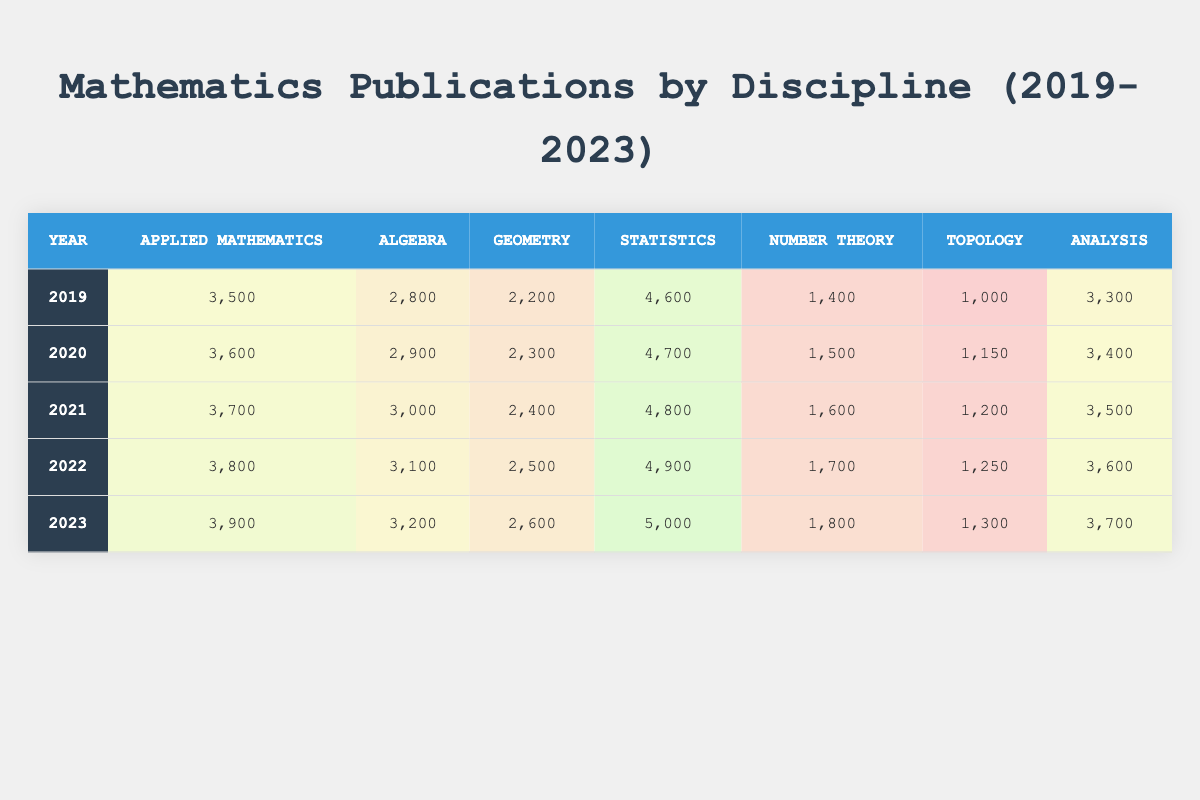What was the number of statistics publications in 2021? In the row for the year 2021, the column for statistics shows the value 4,800.
Answer: 4,800 Which discipline had the highest publication count in 2023? In the year 2023, the highest value in the table is found under the statistics column with 5,000 publications.
Answer: Statistics How many publications were there in applied mathematics between 2019 and 2023? The applied mathematics publications for the years 2019 to 2023 are 3,500, 3,600, 3,700, 3,800, and 3,900. Summing these gives 3,500 + 3,600 + 3,700 + 3,800 + 3,900 = 18,500.
Answer: 18,500 What is the average number of publications in geometry over the five years? The geometry publications are 2,200, 2,300, 2,400, 2,500, and 2,600. To find the average, sum these values (2,200 + 2,300 + 2,400 + 2,500 + 2,600 = 12,000) and divide by 5, giving 12,000 / 5 = 2,400.
Answer: 2,400 Did the number of publications in number theory increase every year from 2019 to 2023? Looking at the number theory column, the values from 2019 (1,400) to 2023 (1,800) show a consistent increase each year: 1,400 < 1,500 < 1,600 < 1,700 < 1,800.
Answer: Yes What was the total number of publications across all disciplines in 2022? The total for 2022 is calculated by adding all disciplines: 3,800 (applied mathematics) + 3,100 (algebra) + 2,500 (geometry) + 4,900 (statistics) + 1,700 (number theory) + 1,250 (topology) + 3,600 (analysis) = 20,850.
Answer: 20,850 In which year did topology see its highest number of publications? In the topology column, the numbers are 1,000 for 2019, 1,150 for 2020, 1,200 for 2021, 1,250 for 2022, and 1,300 for 2023. The highest value is in the year 2023.
Answer: 2023 What is the difference between the highest and lowest publication counts in algebra across the years? The highest count in algebra is 3,200 (2023) and the lowest is 2,800 (2019). The difference is 3,200 - 2,800 = 400.
Answer: 400 Which discipline saw an increase of 300 publications from 2022 to 2023? By comparing the values in the 2022 and 2023 rows for each discipline, applied mathematics increased from 3,800 to 3,900, meaning an increase of 100, and algebra from 3,100 to 3,200, meaning an increase of 100. Geometry increased from 2,500 to 2,600, also 100. Statistics, however, increased from 4,900 to 5,000, which is 100. None of these showed a 300 increase, therefore, the answer is that no discipline saw a 300 increase.
Answer: No discipline showed a 300 increase 